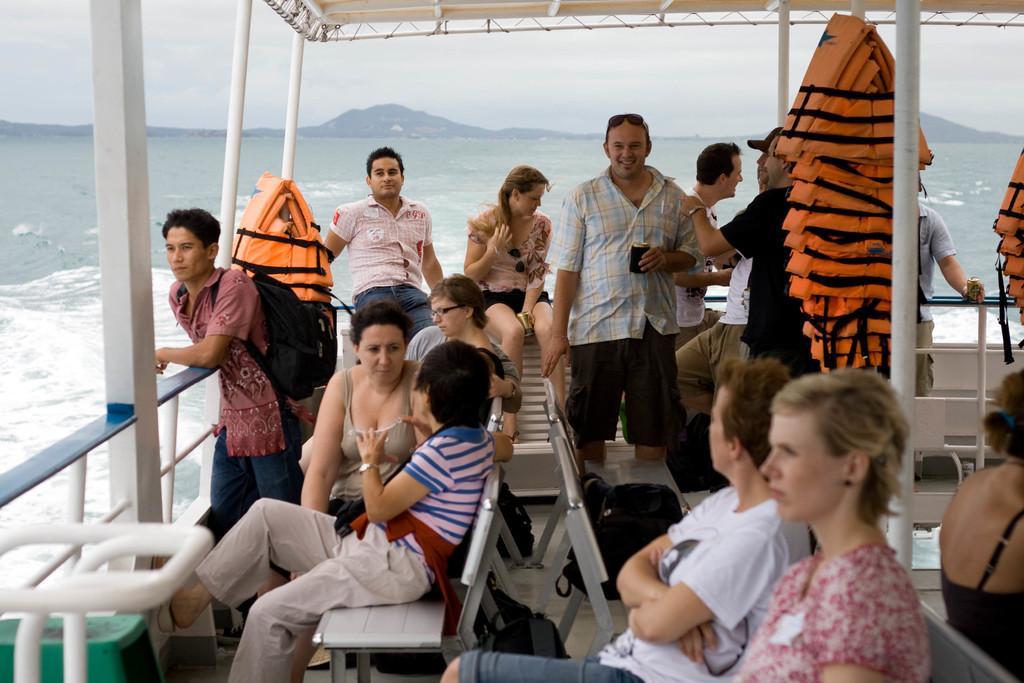How would you summarize this image in a sentence or two? In this image I can see number of people where few are standing and most of them are sitting. I can also see number of orange colour life jackets and on the left side I can see one person is carrying a bag. In the background I can see water, mountains and the sky. I can also see number of poles in the front. 